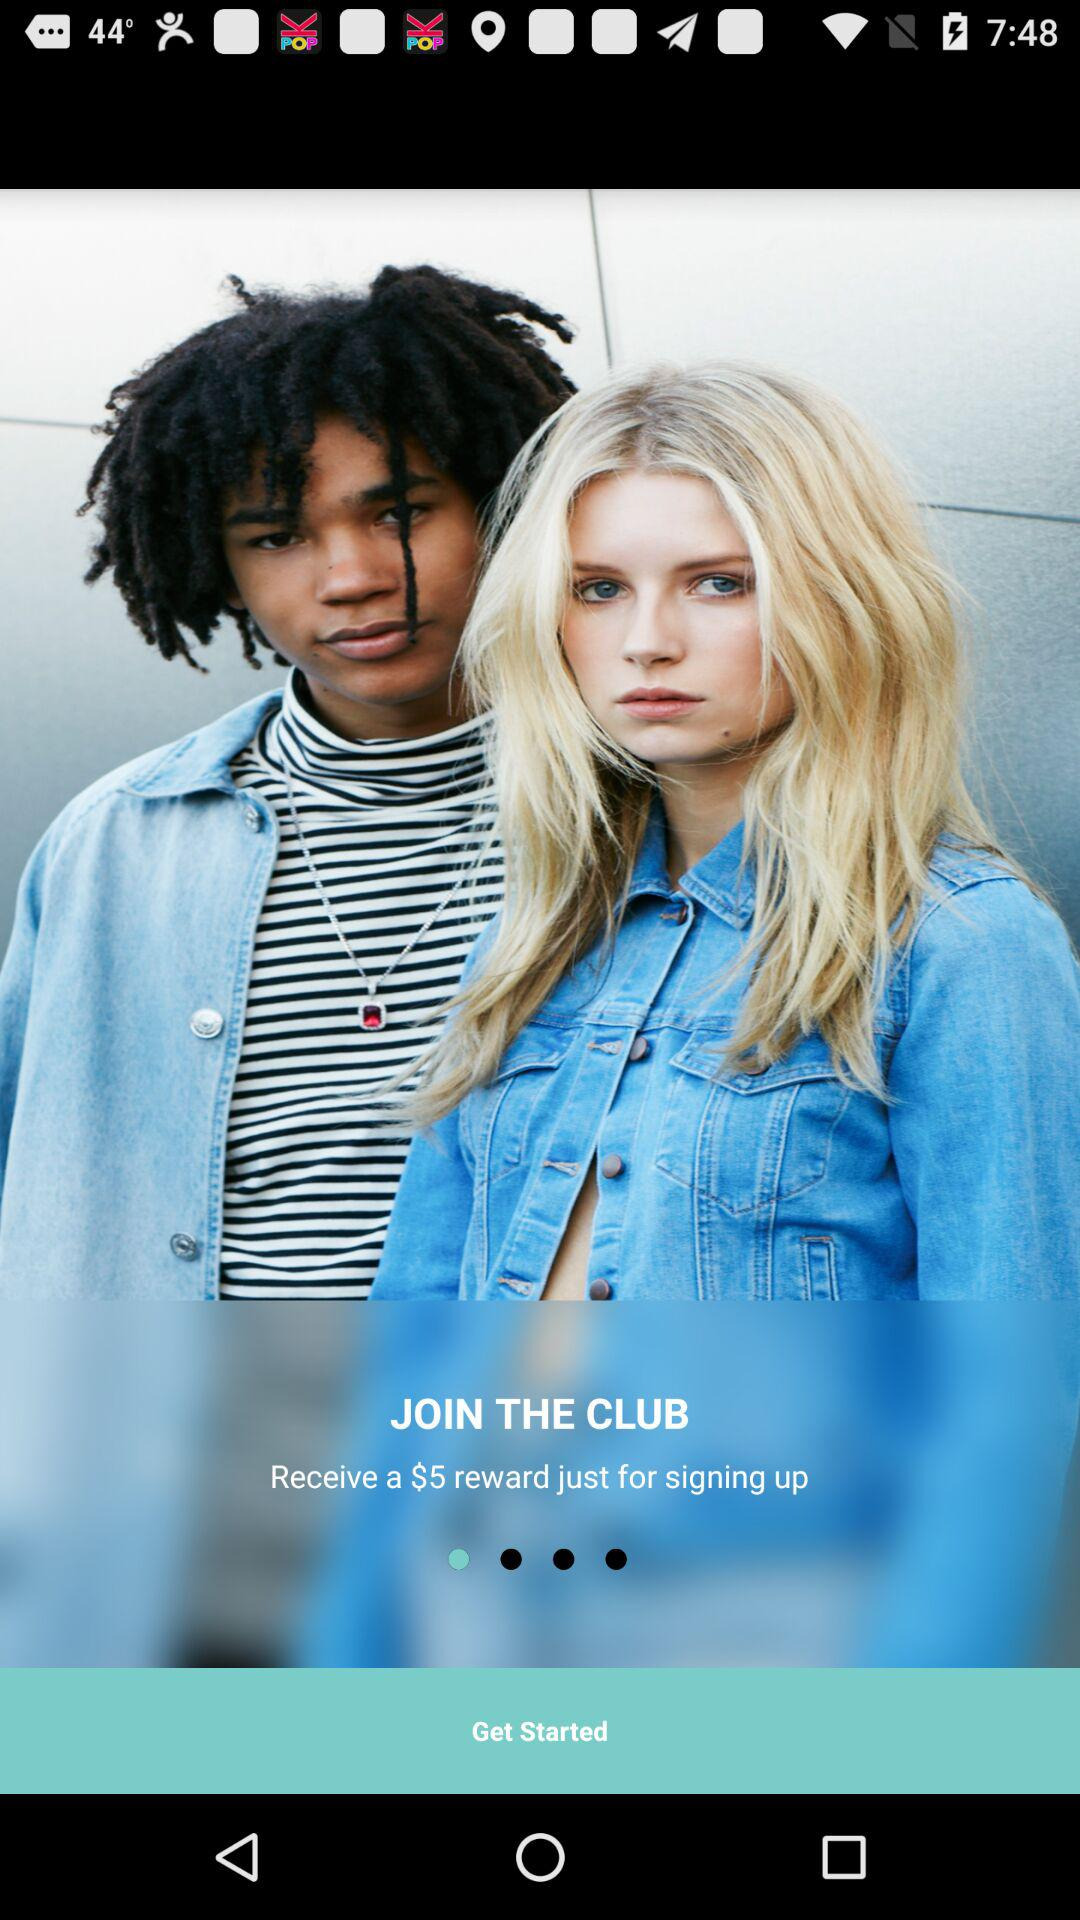If you sign up for the club, how much money will you receive?
Answer the question using a single word or phrase. $5 